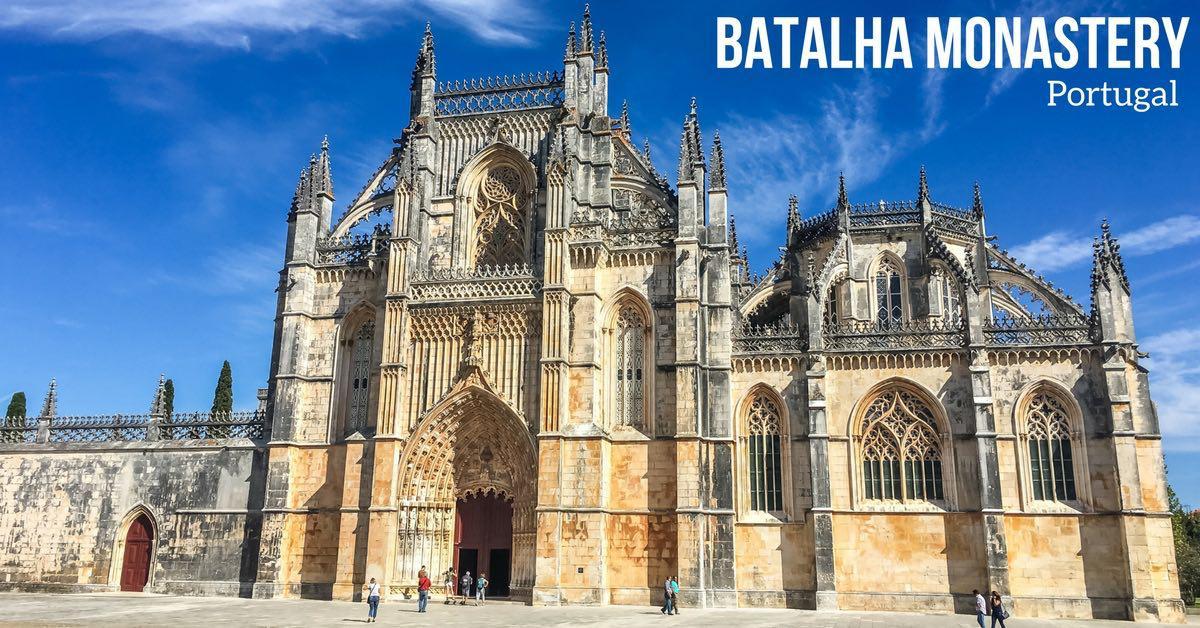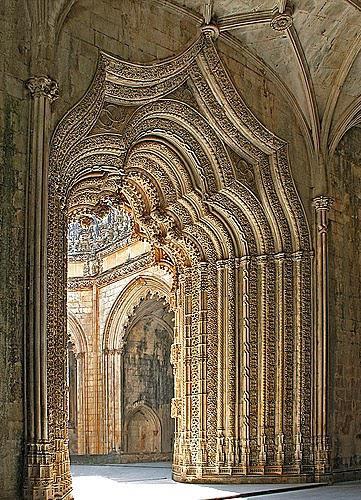The first image is the image on the left, the second image is the image on the right. Analyze the images presented: Is the assertion "The image on the left doesn't show the turrets of the castle." valid? Answer yes or no. No. The first image is the image on the left, the second image is the image on the right. For the images displayed, is the sentence "An image shows multiple people standing in front of a massive archway." factually correct? Answer yes or no. Yes. 